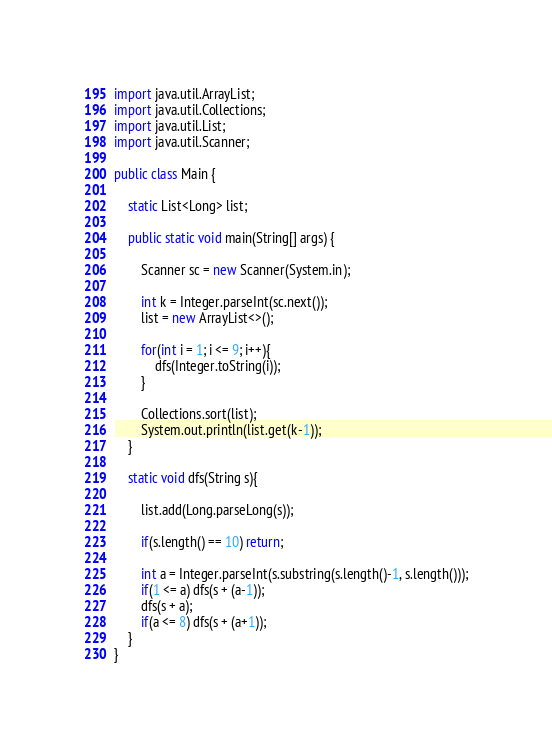<code> <loc_0><loc_0><loc_500><loc_500><_Java_>import java.util.ArrayList;
import java.util.Collections;
import java.util.List;
import java.util.Scanner;

public class Main {
    
    static List<Long> list;

    public static void main(String[] args) {
        
        Scanner sc = new Scanner(System.in);
        
        int k = Integer.parseInt(sc.next());
        list = new ArrayList<>();
        
        for(int i = 1; i <= 9; i++){
            dfs(Integer.toString(i));
        }
        
        Collections.sort(list);
        System.out.println(list.get(k-1));
    }
    
    static void dfs(String s){
        
        list.add(Long.parseLong(s));
        
        if(s.length() == 10) return;
        
        int a = Integer.parseInt(s.substring(s.length()-1, s.length()));
        if(1 <= a) dfs(s + (a-1));
        dfs(s + a);
        if(a <= 8) dfs(s + (a+1));
    }
}</code> 